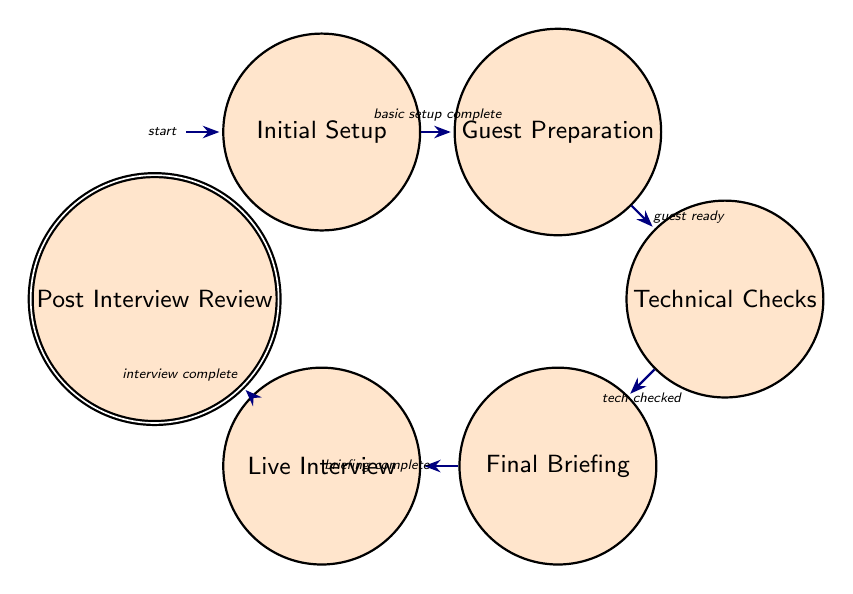What is the first state in the diagram? The first state in the diagram is indicated as the initial state, which is called "Initial Setup." It is the starting point before any preparations begin.
Answer: Initial Setup How many states are there in total? To answer this, we count all the unique states listed in the diagram. There are six distinct states: Initial Setup, Guest Preparation, Technical Checks, Final Briefing, Live Interview, and Post Interview Review.
Answer: Six What is the transition event from "Guest Preparation" to "Technical Checks"? The transition between "Guest Preparation" and "Technical Checks" is described by the event labeled as "guest ready." This indicates that the transition occurs once the guest is adequately prepared.
Answer: Guest Ready Which state comes after "Final Briefing"? Based on the progression of states in the diagram, the state that follows "Final Briefing" is "Live Interview." This indicates that once the final briefing is complete, the live interview session begins.
Answer: Live Interview What are the events leading to the "Post Interview Review"? To reach the "Post Interview Review" state, the flow goes through two transition events: first, completing the "Live Interview," followed by transitioning to "Post Interview Review." Thus, the only event needed to reach this state is "interview complete."
Answer: Interview Complete Which state has the transition event labeled "tech checked"? The transition event "tech checked" connects "Technical Checks" to "Final Briefing." This implies that once technical checks are confirmed to be satisfactory, the process can proceed to the final briefing with the guest and production team.
Answer: Technical Checks What is the final state of the flow? The final state in the progression of the finite state machine is "Post Interview Review." This state represents the concluding step where the team reviews the interview's effectiveness after it has been conducted.
Answer: Post Interview Review What is the relationship between "Initial Setup" and "Guest Preparation"? The relationship between "Initial Setup" and "Guest Preparation" is a transition from the first state to the second described by the event "basic setup complete." This indicates progress from the initial setup phase to preparing the guest.
Answer: Basic Setup Complete What is the state before "Live Interview"? The state preceding "Live Interview" in the diagram is "Final Briefing." This indicates that the final preparation stage occurs right before the live interview takes place.
Answer: Final Briefing 